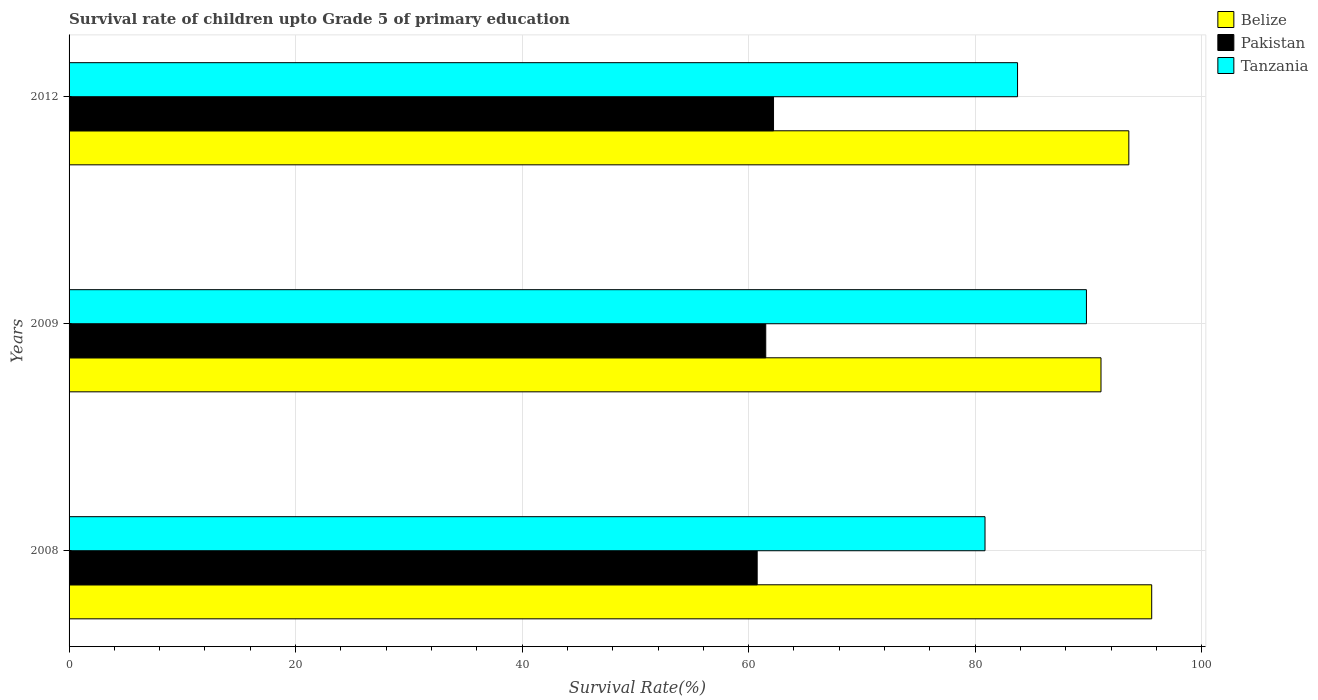How many different coloured bars are there?
Provide a short and direct response. 3. How many groups of bars are there?
Offer a terse response. 3. Are the number of bars on each tick of the Y-axis equal?
Give a very brief answer. Yes. What is the label of the 2nd group of bars from the top?
Ensure brevity in your answer.  2009. What is the survival rate of children in Belize in 2012?
Ensure brevity in your answer.  93.56. Across all years, what is the maximum survival rate of children in Tanzania?
Provide a short and direct response. 89.82. Across all years, what is the minimum survival rate of children in Belize?
Provide a succinct answer. 91.11. In which year was the survival rate of children in Tanzania maximum?
Offer a terse response. 2009. What is the total survival rate of children in Belize in the graph?
Give a very brief answer. 280.25. What is the difference between the survival rate of children in Tanzania in 2008 and that in 2009?
Your answer should be compact. -8.95. What is the difference between the survival rate of children in Belize in 2008 and the survival rate of children in Pakistan in 2012?
Offer a very short reply. 33.39. What is the average survival rate of children in Pakistan per year?
Keep it short and to the point. 61.48. In the year 2009, what is the difference between the survival rate of children in Pakistan and survival rate of children in Tanzania?
Keep it short and to the point. -28.31. In how many years, is the survival rate of children in Belize greater than 84 %?
Ensure brevity in your answer.  3. What is the ratio of the survival rate of children in Tanzania in 2009 to that in 2012?
Your response must be concise. 1.07. What is the difference between the highest and the second highest survival rate of children in Belize?
Offer a very short reply. 2.02. What is the difference between the highest and the lowest survival rate of children in Belize?
Provide a succinct answer. 4.48. In how many years, is the survival rate of children in Belize greater than the average survival rate of children in Belize taken over all years?
Offer a very short reply. 2. What does the 3rd bar from the top in 2012 represents?
Your response must be concise. Belize. What does the 1st bar from the bottom in 2009 represents?
Give a very brief answer. Belize. Is it the case that in every year, the sum of the survival rate of children in Belize and survival rate of children in Tanzania is greater than the survival rate of children in Pakistan?
Your response must be concise. Yes. Are all the bars in the graph horizontal?
Give a very brief answer. Yes. Does the graph contain any zero values?
Your response must be concise. No. How are the legend labels stacked?
Offer a very short reply. Vertical. What is the title of the graph?
Offer a very short reply. Survival rate of children upto Grade 5 of primary education. Does "Bahrain" appear as one of the legend labels in the graph?
Your response must be concise. No. What is the label or title of the X-axis?
Ensure brevity in your answer.  Survival Rate(%). What is the Survival Rate(%) in Belize in 2008?
Make the answer very short. 95.58. What is the Survival Rate(%) in Pakistan in 2008?
Your answer should be compact. 60.75. What is the Survival Rate(%) in Tanzania in 2008?
Offer a very short reply. 80.87. What is the Survival Rate(%) in Belize in 2009?
Provide a short and direct response. 91.11. What is the Survival Rate(%) in Pakistan in 2009?
Give a very brief answer. 61.51. What is the Survival Rate(%) in Tanzania in 2009?
Ensure brevity in your answer.  89.82. What is the Survival Rate(%) in Belize in 2012?
Provide a succinct answer. 93.56. What is the Survival Rate(%) in Pakistan in 2012?
Give a very brief answer. 62.19. What is the Survival Rate(%) in Tanzania in 2012?
Give a very brief answer. 83.74. Across all years, what is the maximum Survival Rate(%) of Belize?
Your answer should be very brief. 95.58. Across all years, what is the maximum Survival Rate(%) in Pakistan?
Provide a short and direct response. 62.19. Across all years, what is the maximum Survival Rate(%) of Tanzania?
Provide a short and direct response. 89.82. Across all years, what is the minimum Survival Rate(%) of Belize?
Your response must be concise. 91.11. Across all years, what is the minimum Survival Rate(%) in Pakistan?
Give a very brief answer. 60.75. Across all years, what is the minimum Survival Rate(%) in Tanzania?
Make the answer very short. 80.87. What is the total Survival Rate(%) of Belize in the graph?
Your answer should be very brief. 280.25. What is the total Survival Rate(%) of Pakistan in the graph?
Make the answer very short. 184.45. What is the total Survival Rate(%) in Tanzania in the graph?
Your response must be concise. 254.42. What is the difference between the Survival Rate(%) in Belize in 2008 and that in 2009?
Offer a very short reply. 4.48. What is the difference between the Survival Rate(%) of Pakistan in 2008 and that in 2009?
Make the answer very short. -0.76. What is the difference between the Survival Rate(%) in Tanzania in 2008 and that in 2009?
Your answer should be compact. -8.95. What is the difference between the Survival Rate(%) in Belize in 2008 and that in 2012?
Your answer should be compact. 2.02. What is the difference between the Survival Rate(%) of Pakistan in 2008 and that in 2012?
Make the answer very short. -1.44. What is the difference between the Survival Rate(%) of Tanzania in 2008 and that in 2012?
Keep it short and to the point. -2.87. What is the difference between the Survival Rate(%) in Belize in 2009 and that in 2012?
Give a very brief answer. -2.46. What is the difference between the Survival Rate(%) in Pakistan in 2009 and that in 2012?
Offer a very short reply. -0.69. What is the difference between the Survival Rate(%) of Tanzania in 2009 and that in 2012?
Offer a terse response. 6.08. What is the difference between the Survival Rate(%) of Belize in 2008 and the Survival Rate(%) of Pakistan in 2009?
Give a very brief answer. 34.07. What is the difference between the Survival Rate(%) in Belize in 2008 and the Survival Rate(%) in Tanzania in 2009?
Keep it short and to the point. 5.76. What is the difference between the Survival Rate(%) in Pakistan in 2008 and the Survival Rate(%) in Tanzania in 2009?
Your response must be concise. -29.07. What is the difference between the Survival Rate(%) of Belize in 2008 and the Survival Rate(%) of Pakistan in 2012?
Your answer should be compact. 33.39. What is the difference between the Survival Rate(%) in Belize in 2008 and the Survival Rate(%) in Tanzania in 2012?
Provide a short and direct response. 11.85. What is the difference between the Survival Rate(%) in Pakistan in 2008 and the Survival Rate(%) in Tanzania in 2012?
Ensure brevity in your answer.  -22.99. What is the difference between the Survival Rate(%) of Belize in 2009 and the Survival Rate(%) of Pakistan in 2012?
Offer a terse response. 28.91. What is the difference between the Survival Rate(%) of Belize in 2009 and the Survival Rate(%) of Tanzania in 2012?
Give a very brief answer. 7.37. What is the difference between the Survival Rate(%) in Pakistan in 2009 and the Survival Rate(%) in Tanzania in 2012?
Provide a short and direct response. -22.23. What is the average Survival Rate(%) of Belize per year?
Ensure brevity in your answer.  93.42. What is the average Survival Rate(%) in Pakistan per year?
Offer a very short reply. 61.48. What is the average Survival Rate(%) in Tanzania per year?
Keep it short and to the point. 84.81. In the year 2008, what is the difference between the Survival Rate(%) of Belize and Survival Rate(%) of Pakistan?
Offer a very short reply. 34.83. In the year 2008, what is the difference between the Survival Rate(%) in Belize and Survival Rate(%) in Tanzania?
Provide a short and direct response. 14.72. In the year 2008, what is the difference between the Survival Rate(%) in Pakistan and Survival Rate(%) in Tanzania?
Make the answer very short. -20.12. In the year 2009, what is the difference between the Survival Rate(%) of Belize and Survival Rate(%) of Pakistan?
Keep it short and to the point. 29.6. In the year 2009, what is the difference between the Survival Rate(%) in Belize and Survival Rate(%) in Tanzania?
Your answer should be very brief. 1.28. In the year 2009, what is the difference between the Survival Rate(%) in Pakistan and Survival Rate(%) in Tanzania?
Provide a succinct answer. -28.31. In the year 2012, what is the difference between the Survival Rate(%) in Belize and Survival Rate(%) in Pakistan?
Provide a short and direct response. 31.37. In the year 2012, what is the difference between the Survival Rate(%) of Belize and Survival Rate(%) of Tanzania?
Give a very brief answer. 9.83. In the year 2012, what is the difference between the Survival Rate(%) in Pakistan and Survival Rate(%) in Tanzania?
Your response must be concise. -21.54. What is the ratio of the Survival Rate(%) in Belize in 2008 to that in 2009?
Keep it short and to the point. 1.05. What is the ratio of the Survival Rate(%) of Tanzania in 2008 to that in 2009?
Make the answer very short. 0.9. What is the ratio of the Survival Rate(%) of Belize in 2008 to that in 2012?
Give a very brief answer. 1.02. What is the ratio of the Survival Rate(%) of Pakistan in 2008 to that in 2012?
Ensure brevity in your answer.  0.98. What is the ratio of the Survival Rate(%) of Tanzania in 2008 to that in 2012?
Ensure brevity in your answer.  0.97. What is the ratio of the Survival Rate(%) in Belize in 2009 to that in 2012?
Make the answer very short. 0.97. What is the ratio of the Survival Rate(%) in Tanzania in 2009 to that in 2012?
Keep it short and to the point. 1.07. What is the difference between the highest and the second highest Survival Rate(%) of Belize?
Ensure brevity in your answer.  2.02. What is the difference between the highest and the second highest Survival Rate(%) in Pakistan?
Provide a short and direct response. 0.69. What is the difference between the highest and the second highest Survival Rate(%) in Tanzania?
Your answer should be very brief. 6.08. What is the difference between the highest and the lowest Survival Rate(%) of Belize?
Your answer should be compact. 4.48. What is the difference between the highest and the lowest Survival Rate(%) in Pakistan?
Your answer should be compact. 1.44. What is the difference between the highest and the lowest Survival Rate(%) of Tanzania?
Your answer should be compact. 8.95. 